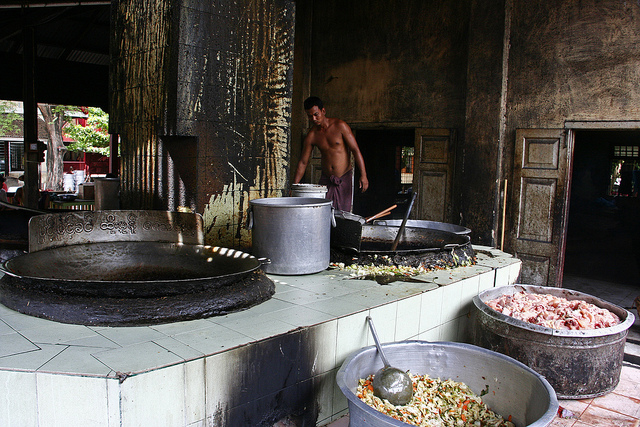<image>Are these people poor? It's unclear if these people are poor. It could be either 'yes' or 'no'. Are these people poor? I don't know if these people are poor. It can be a mix of both poor and not poor. 